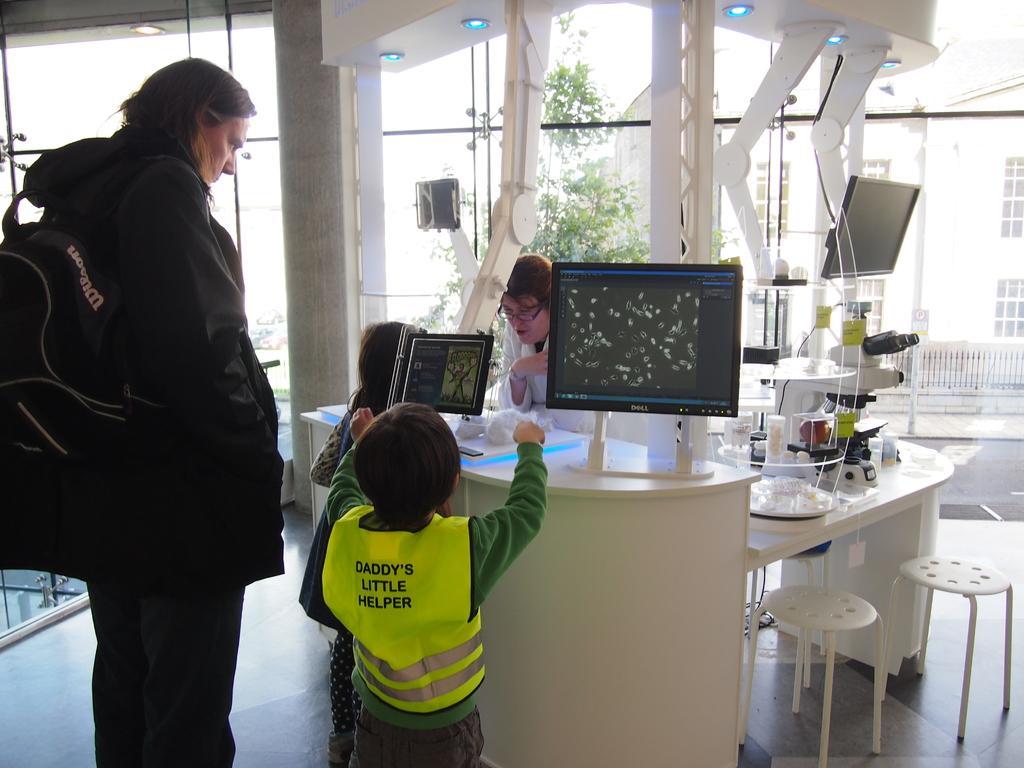In one or two sentences, can you explain what this image depicts? In this image I can see a person wearing black colored dress and black colored bag is standing and a child wearing green colored dress and jacket is standing. I can see a desk, few glass objects, a microscope, few stools and a person wearing white colored dress is standing on the other side of the desk. In the background I can see the glass windows through which I can see another building, few trees and the sky. 